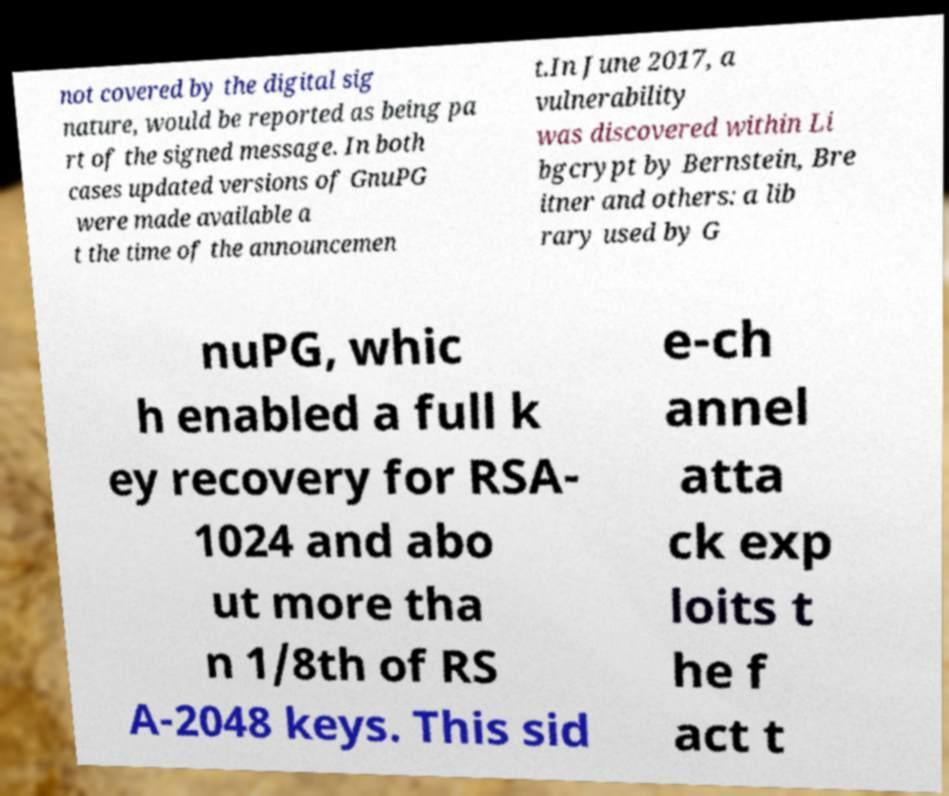Can you read and provide the text displayed in the image?This photo seems to have some interesting text. Can you extract and type it out for me? not covered by the digital sig nature, would be reported as being pa rt of the signed message. In both cases updated versions of GnuPG were made available a t the time of the announcemen t.In June 2017, a vulnerability was discovered within Li bgcrypt by Bernstein, Bre itner and others: a lib rary used by G nuPG, whic h enabled a full k ey recovery for RSA- 1024 and abo ut more tha n 1/8th of RS A-2048 keys. This sid e-ch annel atta ck exp loits t he f act t 